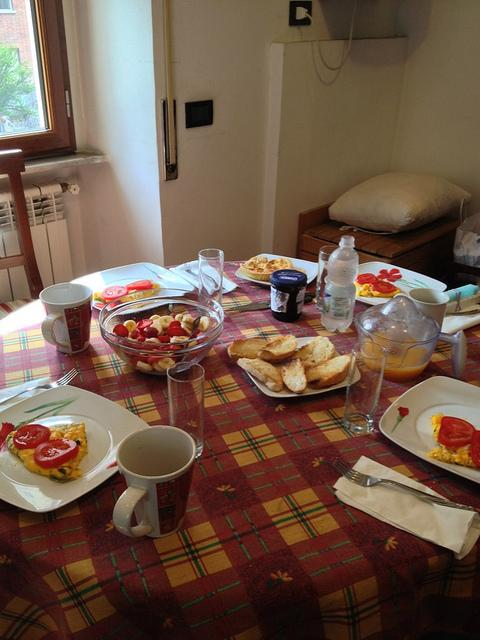What will they serve to drink? orange juice 